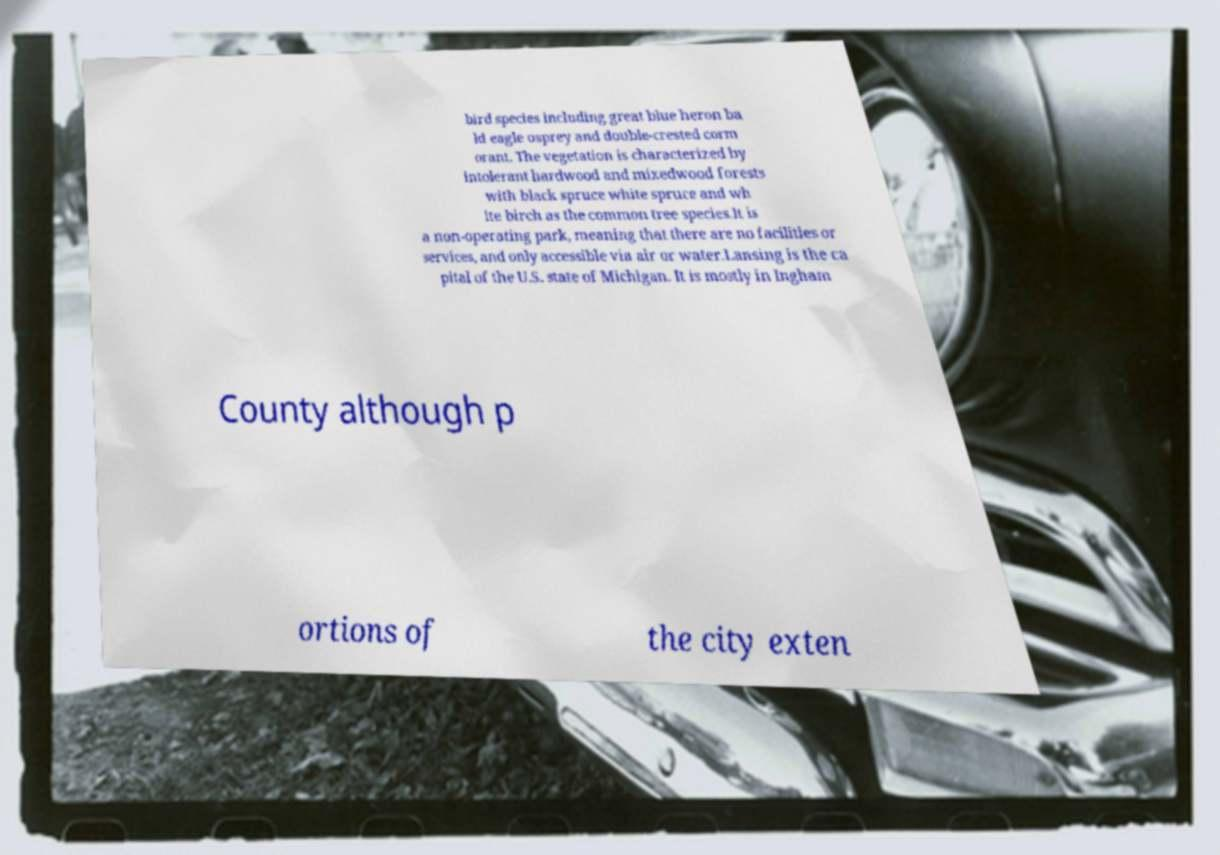Can you read and provide the text displayed in the image?This photo seems to have some interesting text. Can you extract and type it out for me? bird species including great blue heron ba ld eagle osprey and double-crested corm orant. The vegetation is characterized by intolerant hardwood and mixedwood forests with black spruce white spruce and wh ite birch as the common tree species.It is a non-operating park, meaning that there are no facilities or services, and only accessible via air or water.Lansing is the ca pital of the U.S. state of Michigan. It is mostly in Ingham County although p ortions of the city exten 